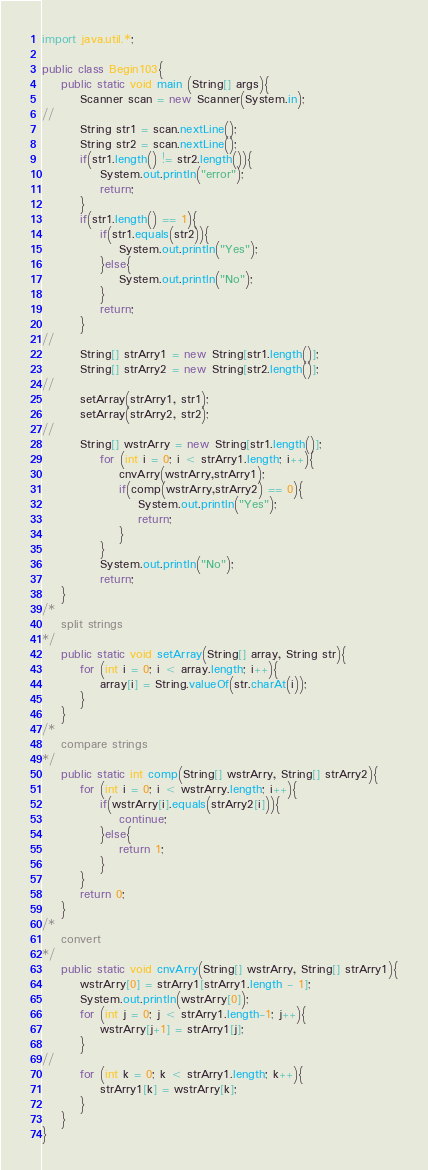Convert code to text. <code><loc_0><loc_0><loc_500><loc_500><_Java_>import java.util.*;

public class Begin103{
    public static void main (String[] args){
        Scanner scan = new Scanner(System.in);
//
        String str1 = scan.nextLine();
        String str2 = scan.nextLine();
        if(str1.length() != str2.length()){
            System.out.println("error");
            return;
        }
        if(str1.length() == 1){
            if(str1.equals(str2)){
                System.out.println("Yes");
            }else{
                System.out.println("No");
            }            
            return;
        }
//
        String[] strArry1 = new String[str1.length()];
        String[] strArry2 = new String[str2.length()];
//
        setArray(strArry1, str1);
        setArray(strArry2, str2);
//
        String[] wstrArry = new String[str1.length()];
            for (int i = 0; i < strArry1.length; i++){
                cnvArry(wstrArry,strArry1);
                if(comp(wstrArry,strArry2) == 0){
                    System.out.println("Yes");
                    return;
                }
            }            
            System.out.println("No");
            return;
    }
/*
    split strings
*/
    public static void setArray(String[] array, String str){
        for (int i = 0; i < array.length; i++){
            array[i] = String.valueOf(str.charAt(i));
        }
    }
/*
    compare strings
*/
    public static int comp(String[] wstrArry, String[] strArry2){
        for (int i = 0; i < wstrArry.length; i++){
            if(wstrArry[i].equals(strArry2[i])){
                continue;
            }else{                
                return 1;
            }
        }
        return 0;        
    }
/*
    convert
*/
    public static void cnvArry(String[] wstrArry, String[] strArry1){
        wstrArry[0] = strArry1[strArry1.length - 1];
        System.out.println(wstrArry[0]);
        for (int j = 0; j < strArry1.length-1; j++){
            wstrArry[j+1] = strArry1[j];
        }
//
        for (int k = 0; k < strArry1.length; k++){
            strArry1[k] = wstrArry[k];
        }
    }
}</code> 